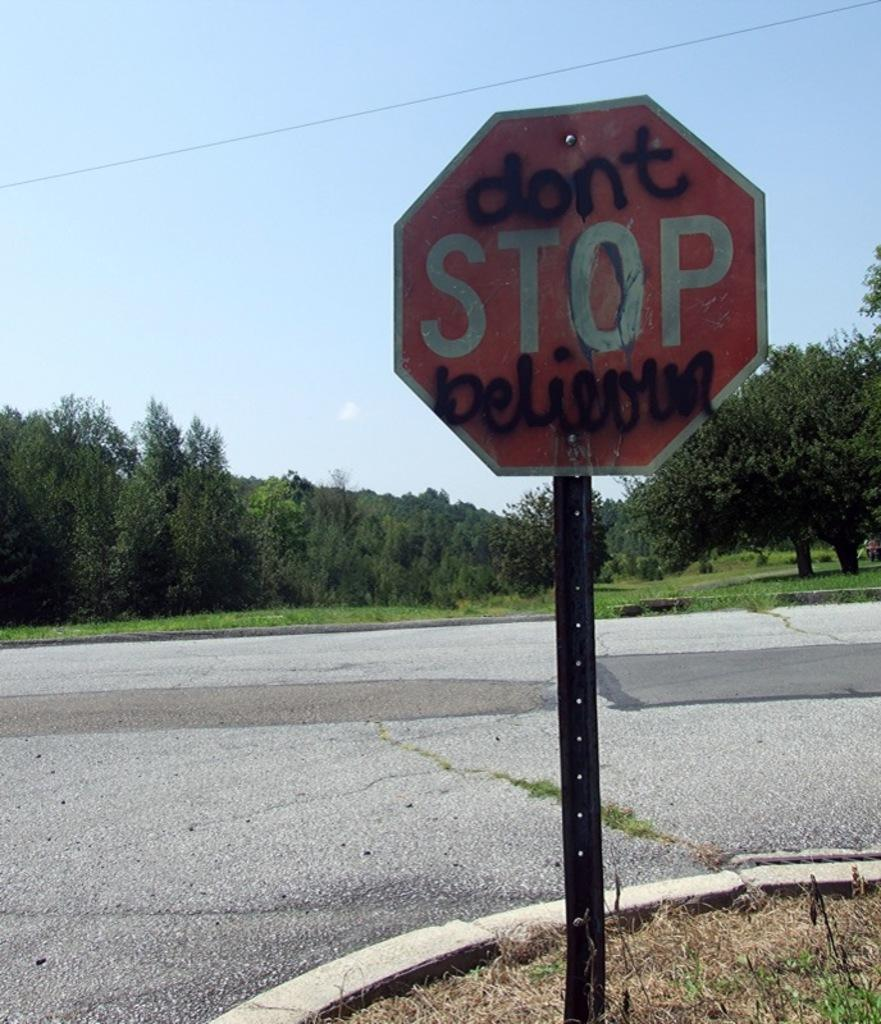<image>
Relay a brief, clear account of the picture shown. A stop sign at a street corner with "don't" and "believun" added in back spray paint. 